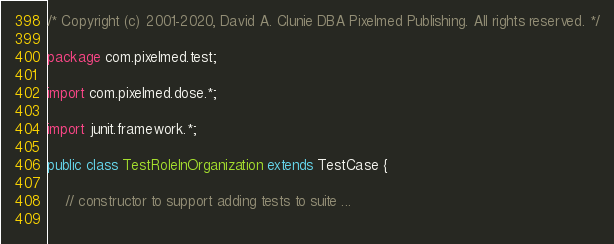Convert code to text. <code><loc_0><loc_0><loc_500><loc_500><_Java_>/* Copyright (c) 2001-2020, David A. Clunie DBA Pixelmed Publishing. All rights reserved. */

package com.pixelmed.test;

import com.pixelmed.dose.*;

import junit.framework.*;

public class TestRoleInOrganization extends TestCase {
	
	// constructor to support adding tests to suite ...
	</code> 